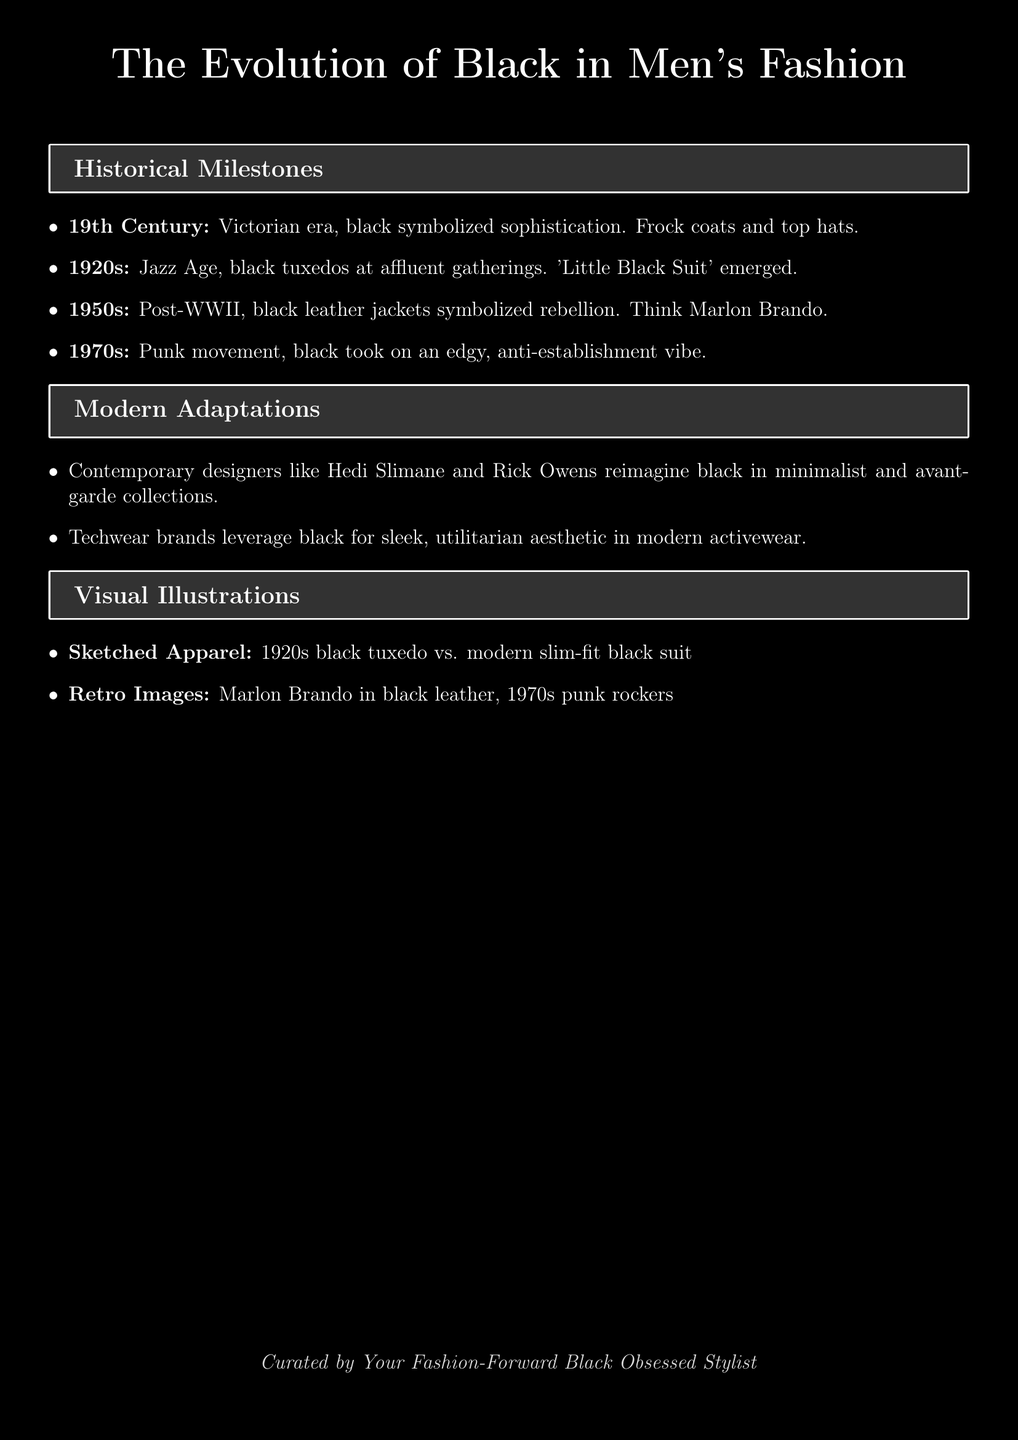What decade is associated with the emergence of the 'Little Black Suit'? The document states that the 'Little Black Suit' emerged in the 1920s during the Jazz Age.
Answer: 1920s What type of outerwear was symbolic of rebellion in the 1950s? The document notes that black leather jackets were symbolic of rebellion in the 1950s.
Answer: leather jackets Which designer is mentioned as reimagining black in minimalist collections? Hedi Slimane is mentioned in the document as a contemporary designer reimagining black in minimalist collections.
Answer: Hedi Slimane What visual illustration contrasts a 1920s attire with modern fashion? The document specifies that the sketched apparel contrasts a 1920s black tuxedo with a modern slim-fit black suit.
Answer: black tuxedo vs. modern slim-fit black suit What cultural movement in the 1970s associated black with an edgy vibe? The punk movement in the 1970s took on an edgy, anti-establishment vibe according to the document.
Answer: Punk movement How is black utilized in contemporary activewear according to the document? Techwear brands leverage black for a sleek, utilitarian aesthetic in modern activewear.
Answer: sleek, utilitarian aesthetic What color symbolizes sophistication in the 19th century men's fashion? The document states that black symbolized sophistication in the 19th century during the Victorian era.
Answer: black Which era is linked to Marlon Brando and a specific type of black apparel? The 1950s is linked to Marlon Brando and black leather apparel as noted in the document.
Answer: 1950s 